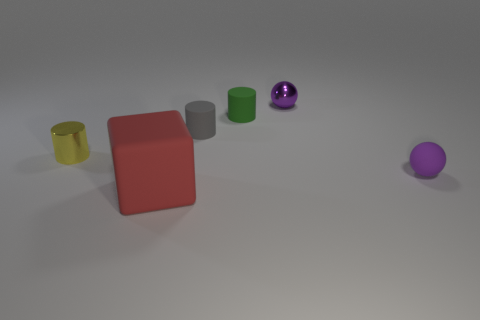What number of yellow things have the same shape as the green matte thing?
Offer a very short reply. 1. What material is the green object?
Provide a short and direct response. Rubber. Does the yellow object have the same shape as the small gray rubber thing?
Provide a succinct answer. Yes. Is there another purple object made of the same material as the large object?
Provide a succinct answer. Yes. The tiny thing that is both in front of the purple metal ball and behind the gray matte cylinder is what color?
Keep it short and to the point. Green. What is the ball that is behind the tiny matte sphere made of?
Ensure brevity in your answer.  Metal. Are there any other tiny green matte objects that have the same shape as the tiny green rubber object?
Offer a terse response. No. What number of other things are there of the same shape as the small green thing?
Keep it short and to the point. 2. There is a tiny gray rubber thing; is its shape the same as the object left of the cube?
Your response must be concise. Yes. Are there any other things that are the same material as the small gray thing?
Keep it short and to the point. Yes. 